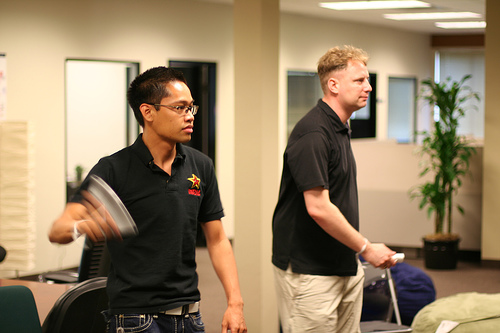What is in the vase? The vase, placed neatly to the right, contains a vibrant green plant adding a touch of nature to the setting. 